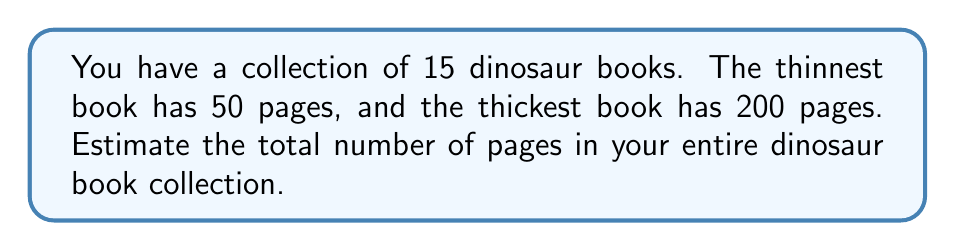Help me with this question. To estimate the total number of pages, we can follow these steps:

1. Find the average number of pages per book:
   $$ \text{Average pages} = \frac{\text{Thinnest book pages} + \text{Thickest book pages}}{2} $$
   $$ \text{Average pages} = \frac{50 + 200}{2} = 125 \text{ pages} $$

2. Multiply the average number of pages by the total number of books:
   $$ \text{Total pages} = \text{Average pages} \times \text{Number of books} $$
   $$ \text{Total pages} = 125 \times 15 = 1875 \text{ pages} $$

This estimation method assumes that the page counts of the books are roughly evenly distributed between the thinnest and thickest books. While this may not be exactly accurate, it provides a reasonable estimate for the total number of pages in the collection.
Answer: 1875 pages 